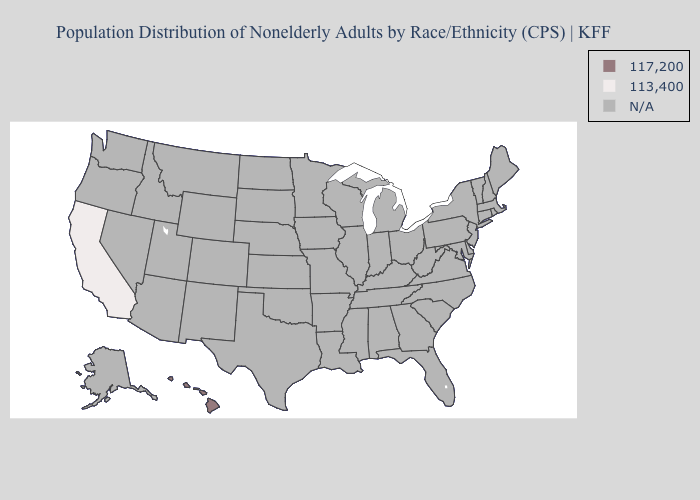What is the value of Missouri?
Quick response, please. N/A. Name the states that have a value in the range N/A?
Answer briefly. Alabama, Alaska, Arizona, Arkansas, Colorado, Connecticut, Delaware, Florida, Georgia, Idaho, Illinois, Indiana, Iowa, Kansas, Kentucky, Louisiana, Maine, Maryland, Massachusetts, Michigan, Minnesota, Mississippi, Missouri, Montana, Nebraska, Nevada, New Hampshire, New Jersey, New Mexico, New York, North Carolina, North Dakota, Ohio, Oklahoma, Oregon, Pennsylvania, Rhode Island, South Carolina, South Dakota, Tennessee, Texas, Utah, Vermont, Virginia, Washington, West Virginia, Wisconsin, Wyoming. Name the states that have a value in the range N/A?
Be succinct. Alabama, Alaska, Arizona, Arkansas, Colorado, Connecticut, Delaware, Florida, Georgia, Idaho, Illinois, Indiana, Iowa, Kansas, Kentucky, Louisiana, Maine, Maryland, Massachusetts, Michigan, Minnesota, Mississippi, Missouri, Montana, Nebraska, Nevada, New Hampshire, New Jersey, New Mexico, New York, North Carolina, North Dakota, Ohio, Oklahoma, Oregon, Pennsylvania, Rhode Island, South Carolina, South Dakota, Tennessee, Texas, Utah, Vermont, Virginia, Washington, West Virginia, Wisconsin, Wyoming. What is the value of Indiana?
Keep it brief. N/A. Name the states that have a value in the range 113,400?
Concise answer only. California. Name the states that have a value in the range N/A?
Answer briefly. Alabama, Alaska, Arizona, Arkansas, Colorado, Connecticut, Delaware, Florida, Georgia, Idaho, Illinois, Indiana, Iowa, Kansas, Kentucky, Louisiana, Maine, Maryland, Massachusetts, Michigan, Minnesota, Mississippi, Missouri, Montana, Nebraska, Nevada, New Hampshire, New Jersey, New Mexico, New York, North Carolina, North Dakota, Ohio, Oklahoma, Oregon, Pennsylvania, Rhode Island, South Carolina, South Dakota, Tennessee, Texas, Utah, Vermont, Virginia, Washington, West Virginia, Wisconsin, Wyoming. Does the first symbol in the legend represent the smallest category?
Keep it brief. No. What is the value of Kansas?
Short answer required. N/A. What is the value of New Mexico?
Be succinct. N/A. What is the value of Alaska?
Short answer required. N/A. What is the value of Florida?
Be succinct. N/A. Does California have the highest value in the USA?
Keep it brief. No. Among the states that border Nevada , which have the lowest value?
Short answer required. California. 